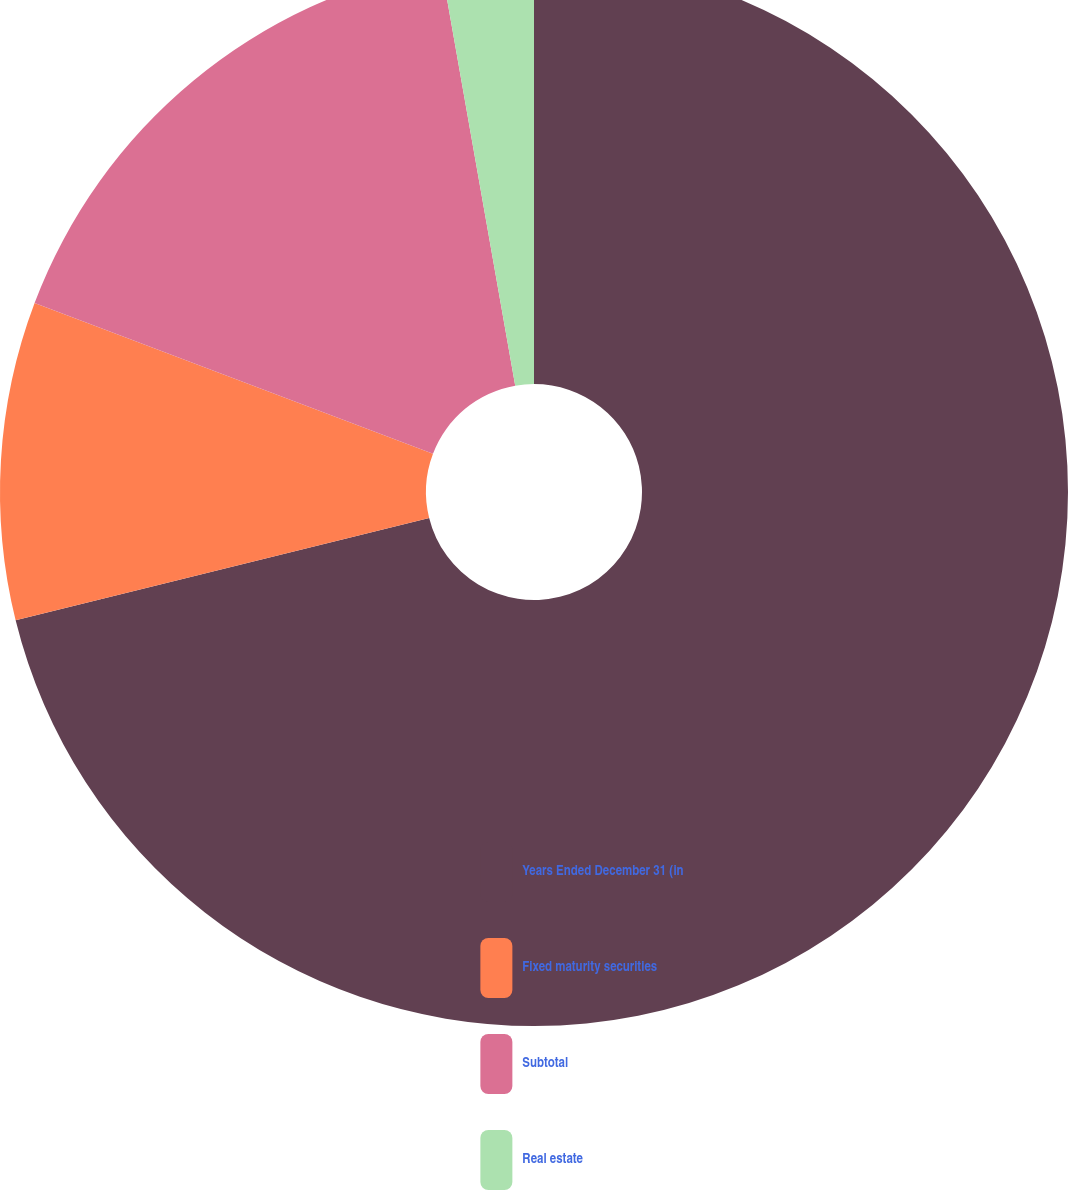Convert chart to OTSL. <chart><loc_0><loc_0><loc_500><loc_500><pie_chart><fcel>Years Ended December 31 (in<fcel>Fixed maturity securities<fcel>Subtotal<fcel>Real estate<nl><fcel>71.14%<fcel>9.62%<fcel>16.46%<fcel>2.78%<nl></chart> 